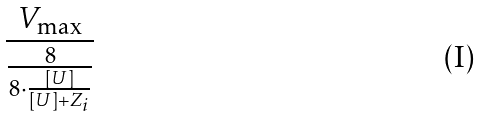Convert formula to latex. <formula><loc_0><loc_0><loc_500><loc_500>\frac { V _ { \max } } { \frac { 8 } { 8 \cdot \frac { [ U ] } { [ U ] + Z _ { i } } } }</formula> 